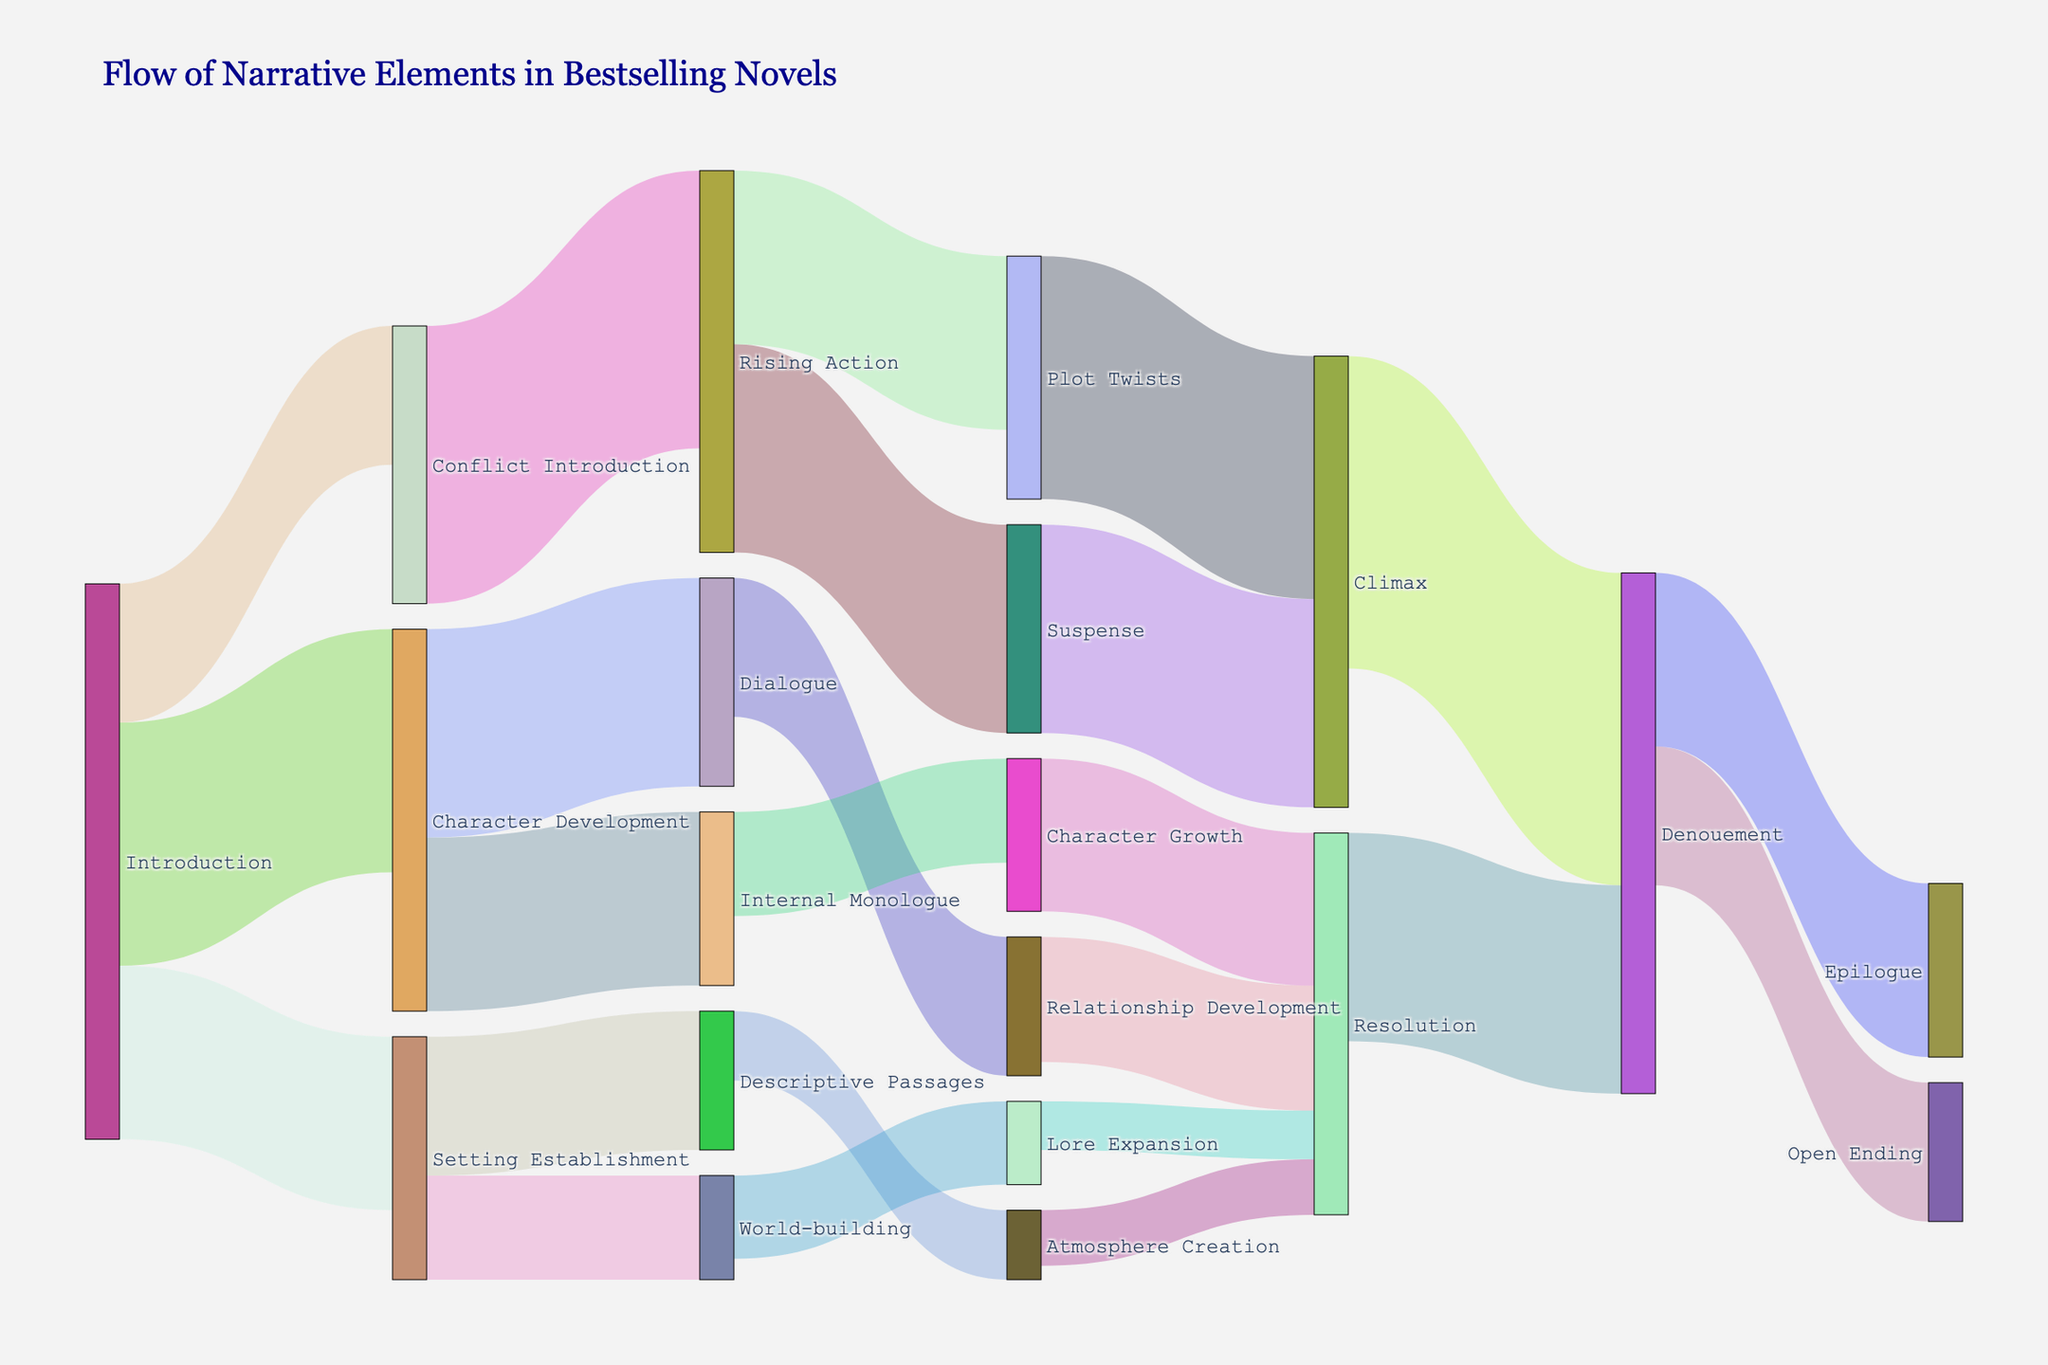What is the most common narrative element introduced in the introduction? The introduction flows into several elements such as Character Development, Setting Establishment, and Conflict Introduction. The values corresponding to these flows are 35, 25, and 20 respectively. The highest value is 35, corresponding to Character Development.
Answer: Character Development Which element has the highest flow value moving into Climax? Climax is reached from Plot Twists and Suspense. The values are 35 and 30 respectively. The highest value is from Plot Twists.
Answer: Plot Twists How many transitions lead to the Denouement? Denouement receives flows from Climax and Resolution. This counts as 2 transitions.
Answer: 2 What is the combined flow value from Dialogue to Relationship Development and Internal Monologue to Character Growth? Dialogue to Relationship Development is 20, and Internal Monologue to Character Growth is 15. The combined flow value is 20 + 15 = 35.
Answer: 35 Which flow has the smallest value and what is it? Among all the values, transitions like Atmosphere Creation to Resolution (8) and Lore Expansion to Resolution (7) have the smallest values. The smallest value is 7.
Answer: 7 What is the total flow value leading into Resolution? Resolution receives flows from Relationship Development, Character Growth, Atmosphere Creation, and Lore Expansion. The respective values are 18, 22, 8, and 7. The total is 18 + 22 + 8 + 7 = 55.
Answer: 55 Compare the flow values between Introduction to Conflict Introduction and Conflict Introduction to Rising Action. Which is higher and by how much? Introduction to Conflict Introduction has a value of 20, while Conflict Introduction to Rising Action has 40. The latter is higher by 40 - 20 = 20.
Answer: Conflict Introduction to Rising Action by 20 What is the final narrative element reached in the diagram? The final elements in the diagram are those with flows leading into them without further outflows. In this case, Epilogue and Open Ending are the final elements.
Answer: Epilogue, Open Ending How many elements are involved in transitions from Suspense to the final narrative elements? Suspense flows to Climax, which then flows to Denouement, which further flows to Epilogue and Open Ending. This involves 4 elements: Climax, Denouement, Epilogue, Open Ending.
Answer: 4 